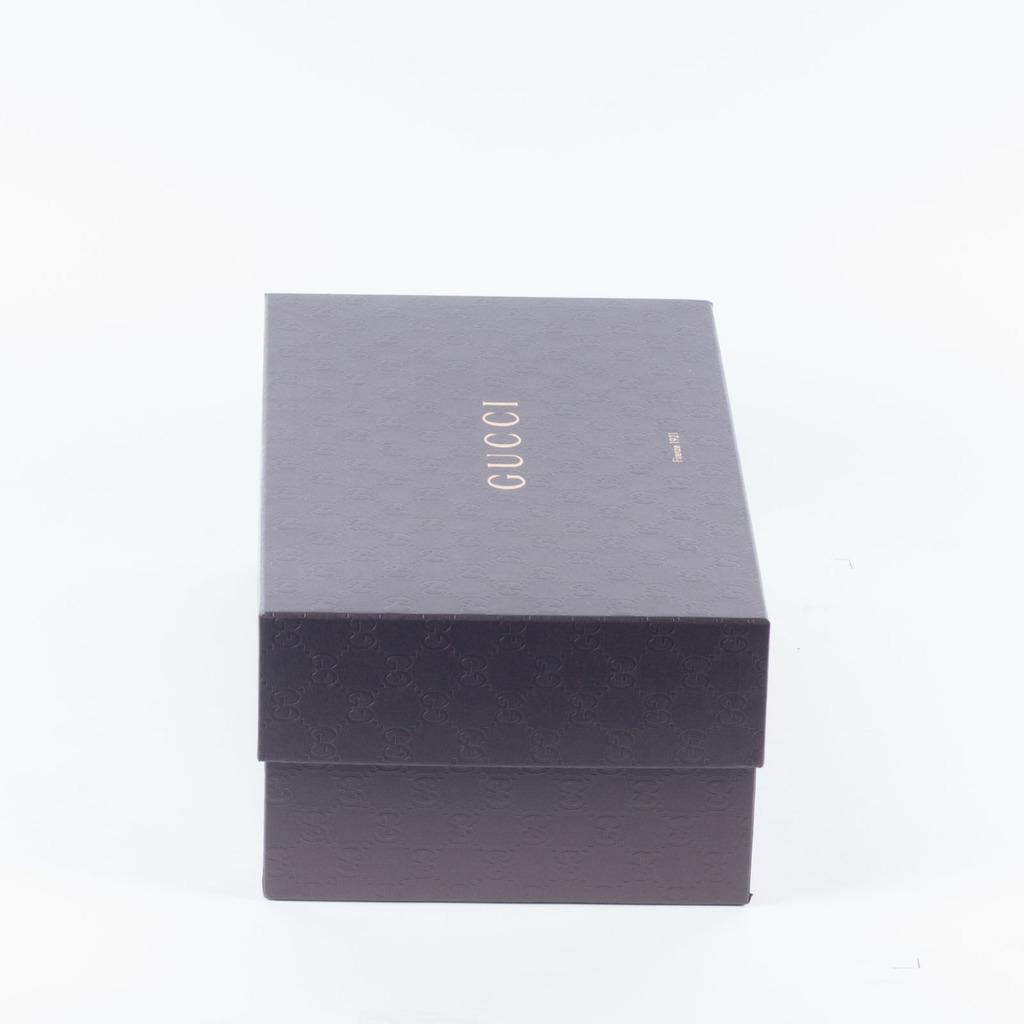<image>
Create a compact narrative representing the image presented. A Gucci box with their iconic branding design around it. 